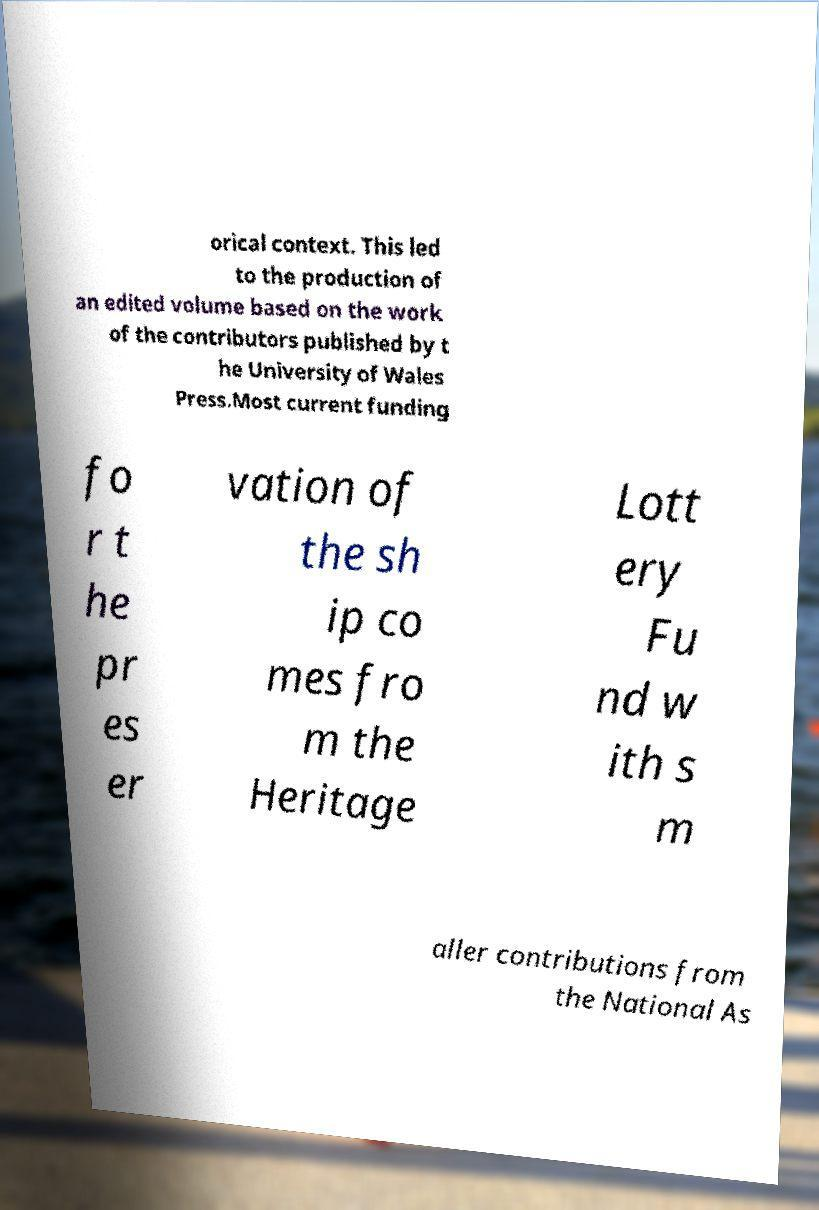For documentation purposes, I need the text within this image transcribed. Could you provide that? orical context. This led to the production of an edited volume based on the work of the contributors published by t he University of Wales Press.Most current funding fo r t he pr es er vation of the sh ip co mes fro m the Heritage Lott ery Fu nd w ith s m aller contributions from the National As 